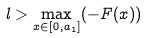<formula> <loc_0><loc_0><loc_500><loc_500>l > \max _ { x \in [ 0 , a _ { 1 } ] } ( - F ( x ) )</formula> 